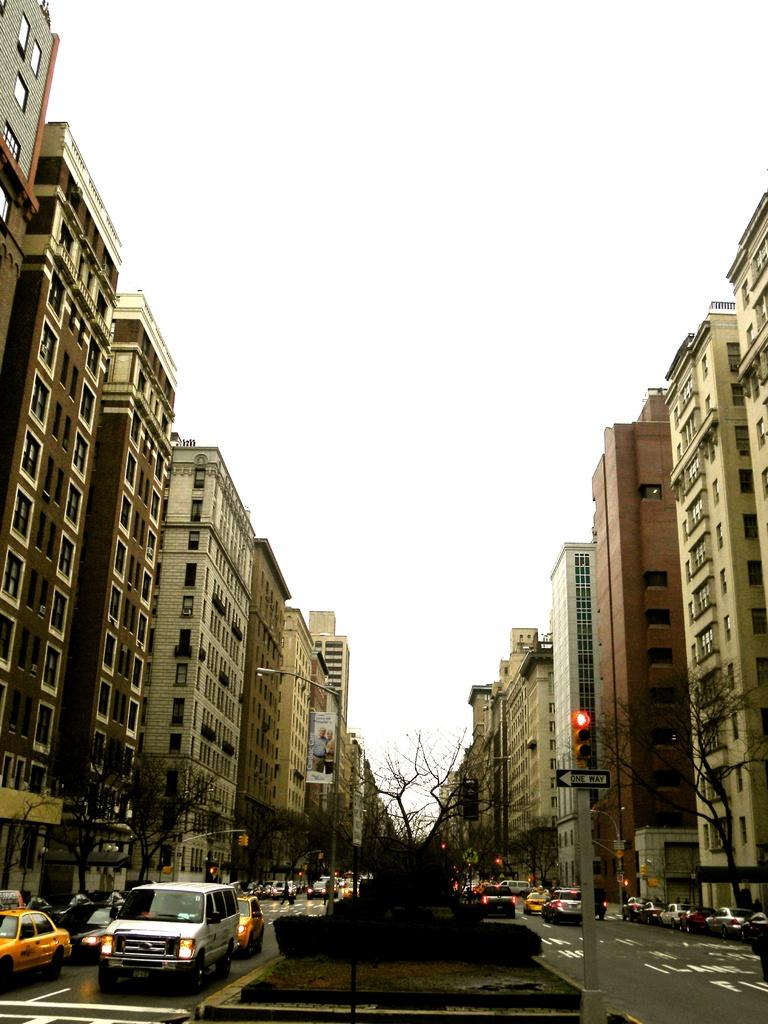What types of objects can be seen in the image? There are vehicles, trees, and buildings in the image. Can you describe the sky in the image? The sky is clear in the image. How many yams are hanging from the trees in the image? There are no yams present in the image; it features vehicles, trees, and buildings. What type of knot is used to secure the buildings in the image? There is no knot used to secure the buildings in the image; they are standing on their own. 